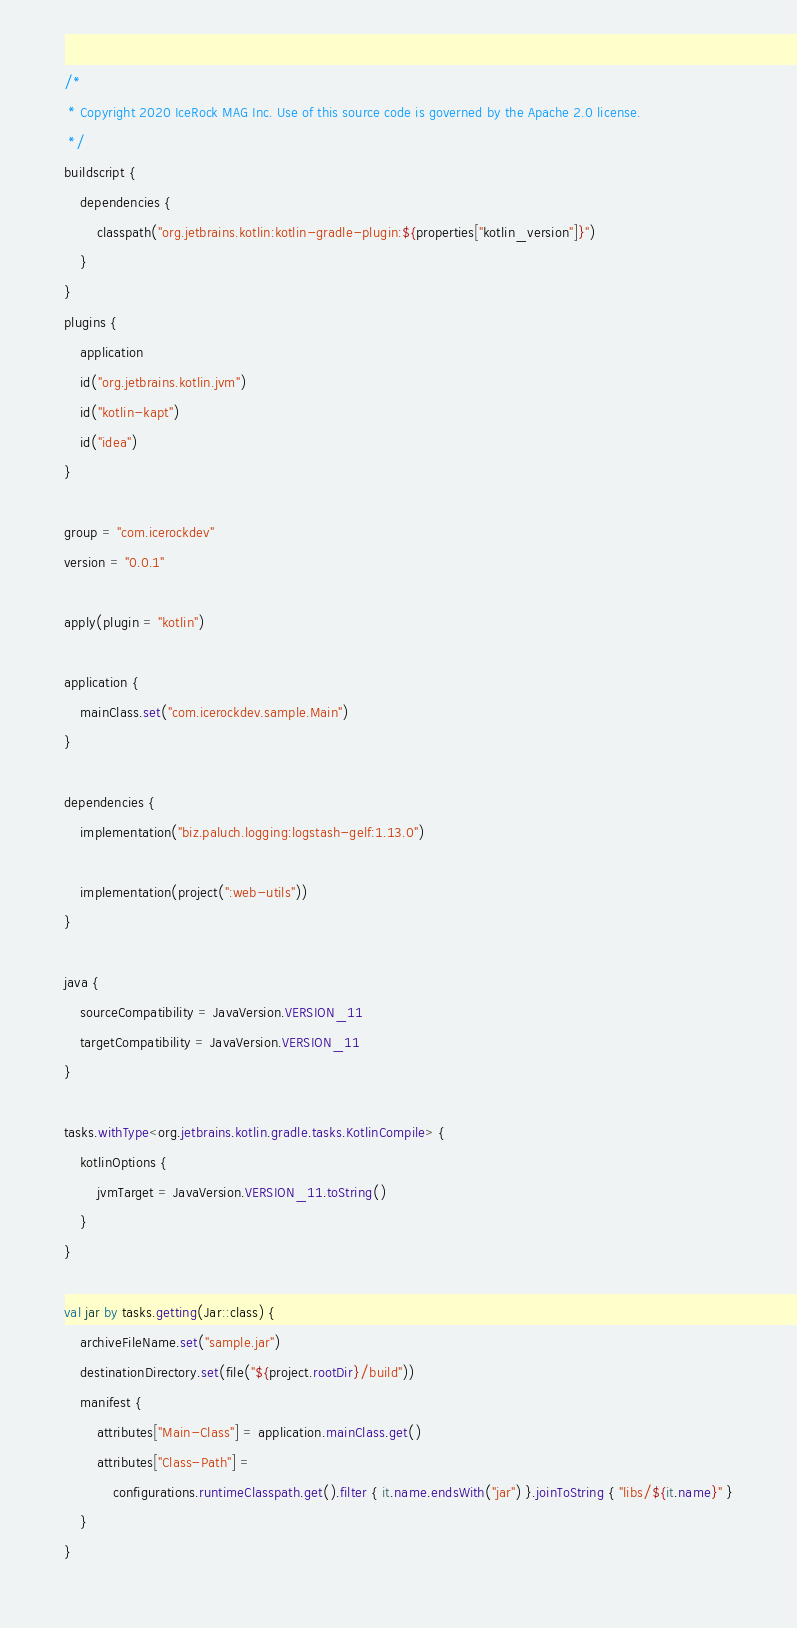Convert code to text. <code><loc_0><loc_0><loc_500><loc_500><_Kotlin_>/*
 * Copyright 2020 IceRock MAG Inc. Use of this source code is governed by the Apache 2.0 license.
 */
buildscript {
    dependencies {
        classpath("org.jetbrains.kotlin:kotlin-gradle-plugin:${properties["kotlin_version"]}")
    }
}
plugins {
    application
    id("org.jetbrains.kotlin.jvm")
    id("kotlin-kapt")
    id("idea")
}

group = "com.icerockdev"
version = "0.0.1"

apply(plugin = "kotlin")

application {
    mainClass.set("com.icerockdev.sample.Main")
}

dependencies {
    implementation("biz.paluch.logging:logstash-gelf:1.13.0")

    implementation(project(":web-utils"))
}

java {
    sourceCompatibility = JavaVersion.VERSION_11
    targetCompatibility = JavaVersion.VERSION_11
}

tasks.withType<org.jetbrains.kotlin.gradle.tasks.KotlinCompile> {
    kotlinOptions {
        jvmTarget = JavaVersion.VERSION_11.toString()
    }
}

val jar by tasks.getting(Jar::class) {
    archiveFileName.set("sample.jar")
    destinationDirectory.set(file("${project.rootDir}/build"))
    manifest {
        attributes["Main-Class"] = application.mainClass.get()
        attributes["Class-Path"] =
            configurations.runtimeClasspath.get().filter { it.name.endsWith("jar") }.joinToString { "libs/${it.name}" }
    }
}
</code> 